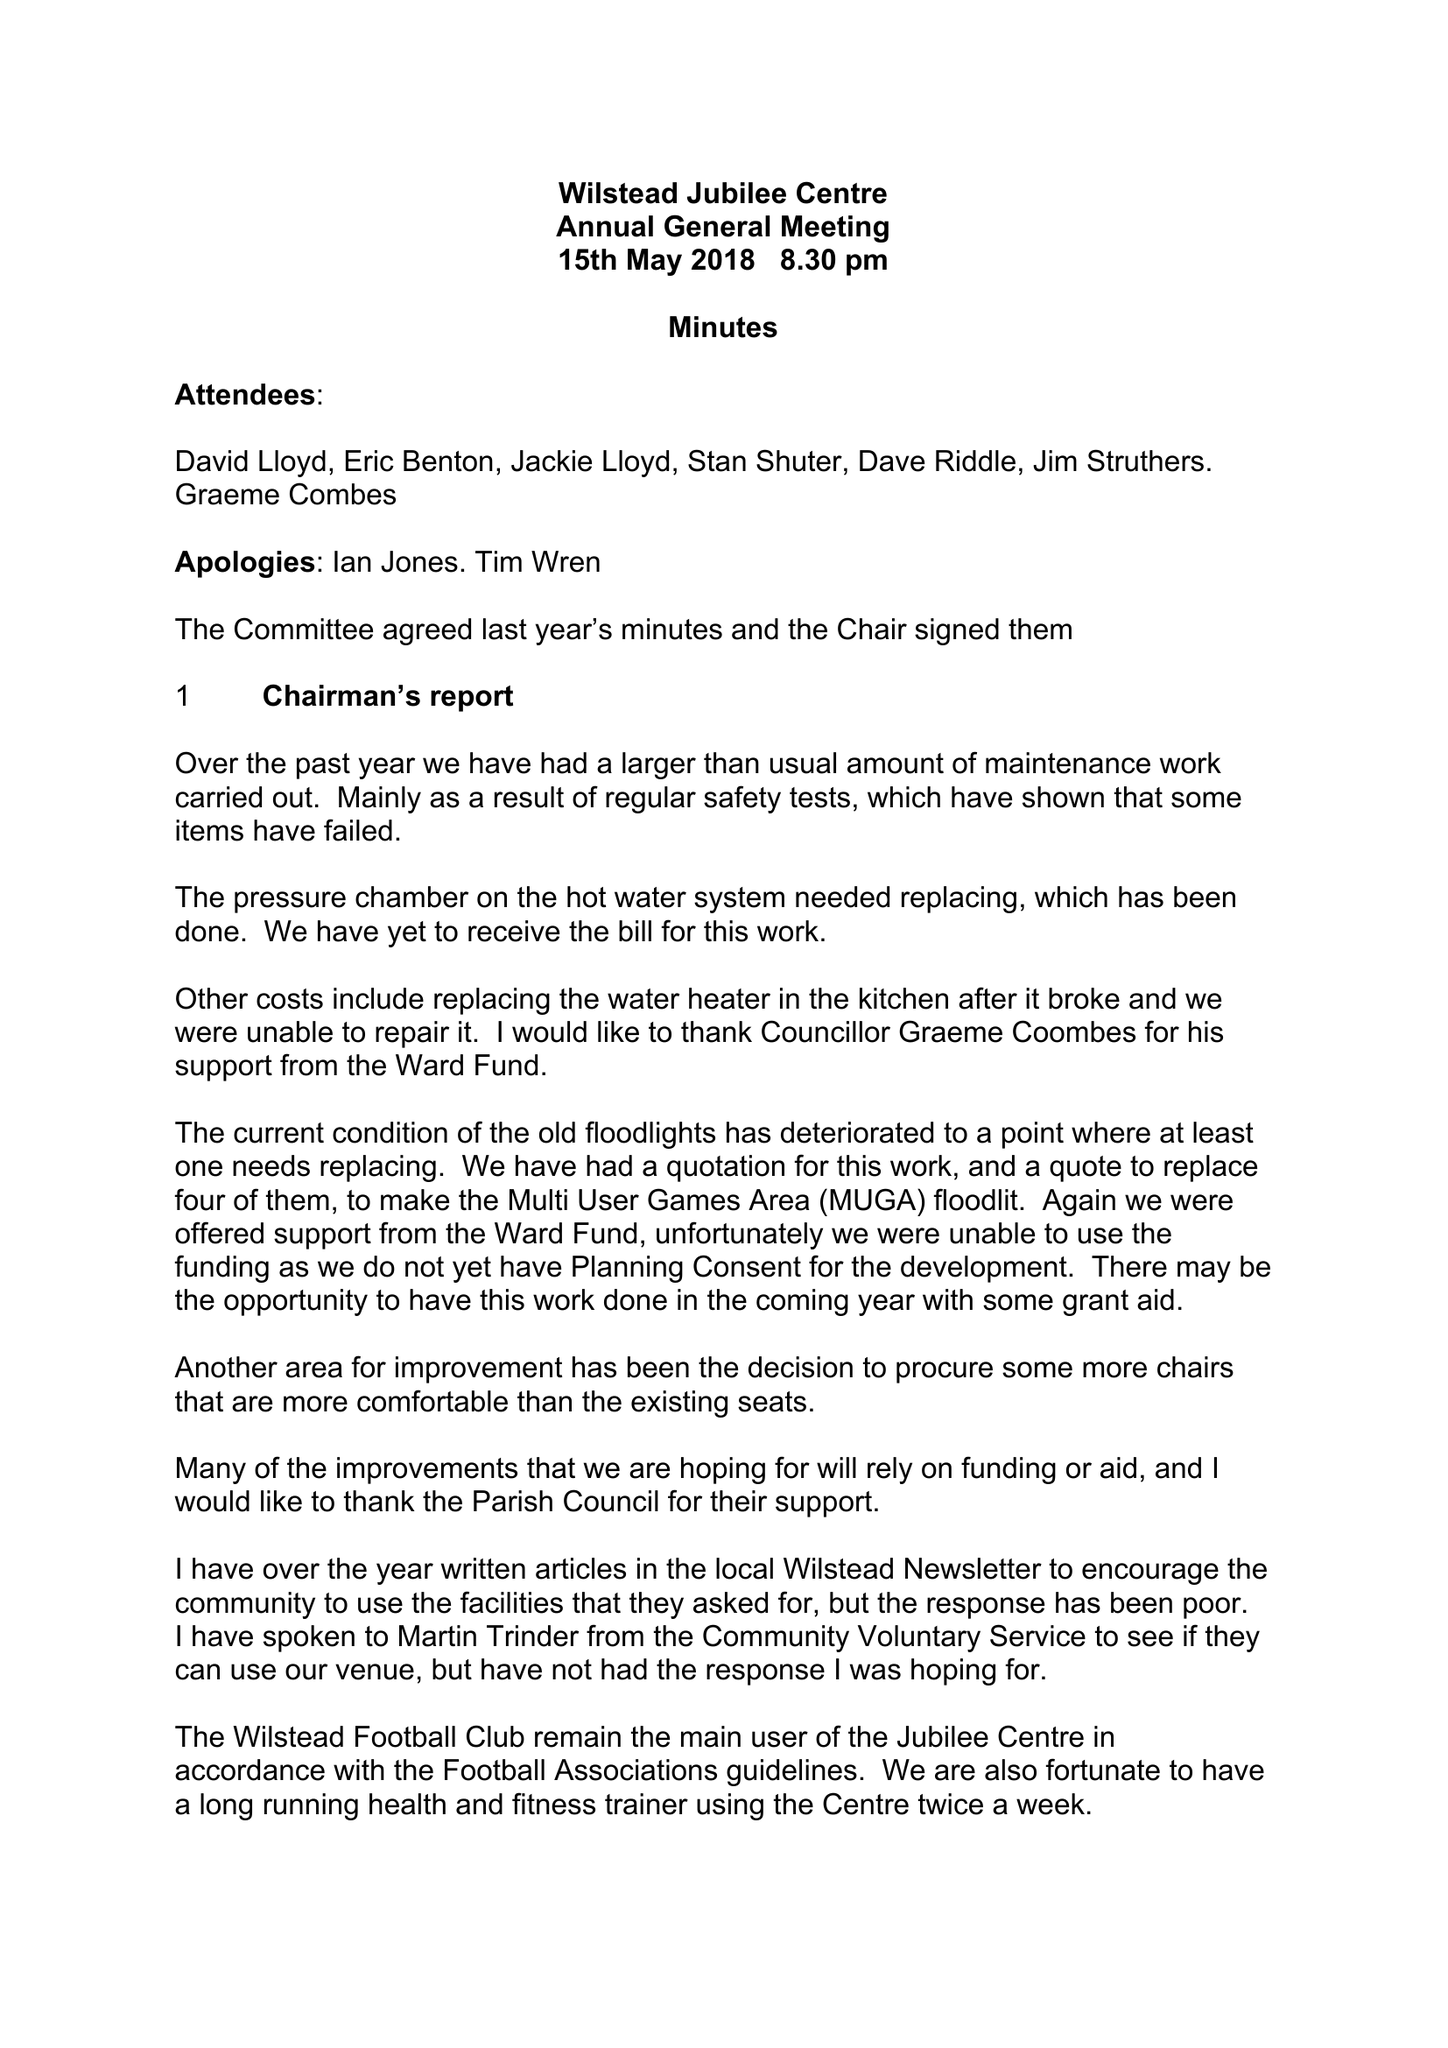What is the value for the address__postcode?
Answer the question using a single word or phrase. MK45 3ER 